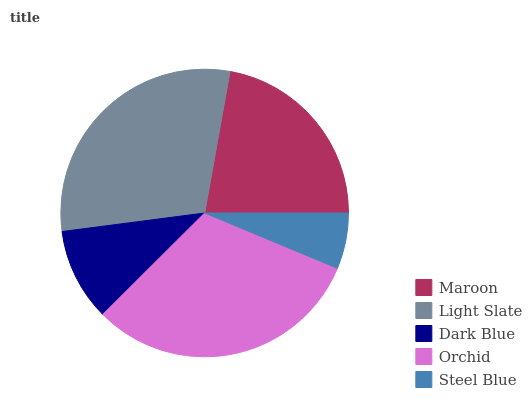Is Steel Blue the minimum?
Answer yes or no. Yes. Is Orchid the maximum?
Answer yes or no. Yes. Is Light Slate the minimum?
Answer yes or no. No. Is Light Slate the maximum?
Answer yes or no. No. Is Light Slate greater than Maroon?
Answer yes or no. Yes. Is Maroon less than Light Slate?
Answer yes or no. Yes. Is Maroon greater than Light Slate?
Answer yes or no. No. Is Light Slate less than Maroon?
Answer yes or no. No. Is Maroon the high median?
Answer yes or no. Yes. Is Maroon the low median?
Answer yes or no. Yes. Is Light Slate the high median?
Answer yes or no. No. Is Dark Blue the low median?
Answer yes or no. No. 